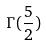Convert formula to latex. <formula><loc_0><loc_0><loc_500><loc_500>\Gamma ( \frac { 5 } { 2 } )</formula> 